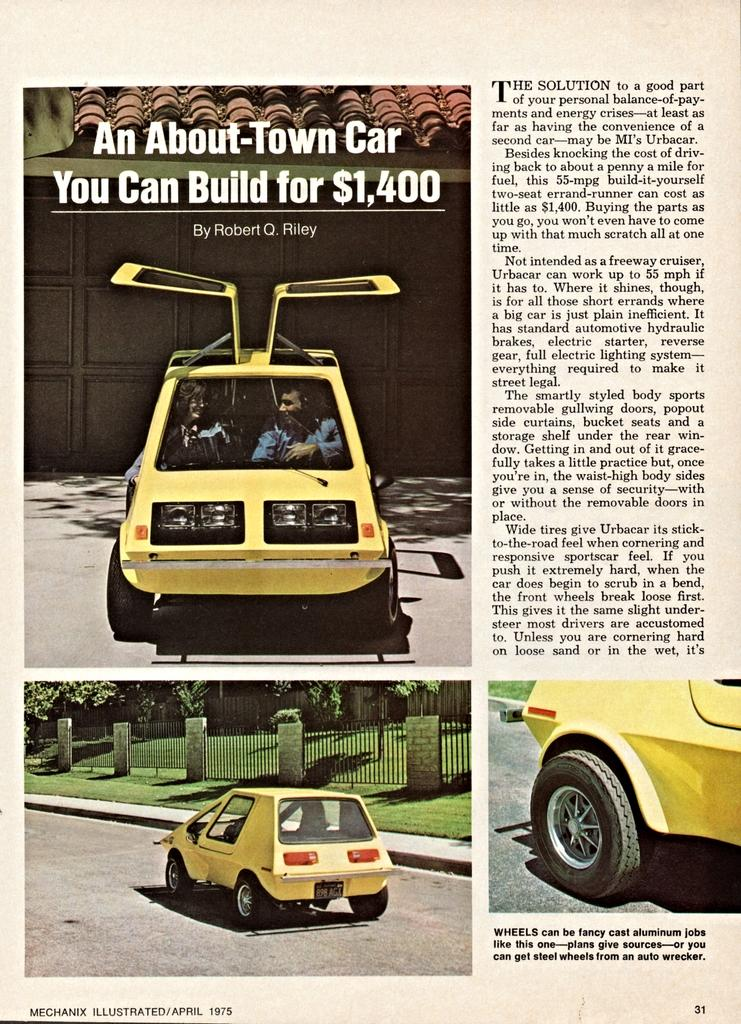What type of media is the image part of? The image is an article in a newspaper. What is the main subject of the image? There is a car in the image. Are there any people in the image? Yes, there are people seated in the car. What color is the car in the image? The car is yellow in color. What type of tent is visible in the image? There is no tent present in the image; it features a car and people seated in it. How does the story in the image shake the reader's emotions? The image is not a story, but rather a photograph in a newspaper article, so it cannot shake the reader's emotions. 